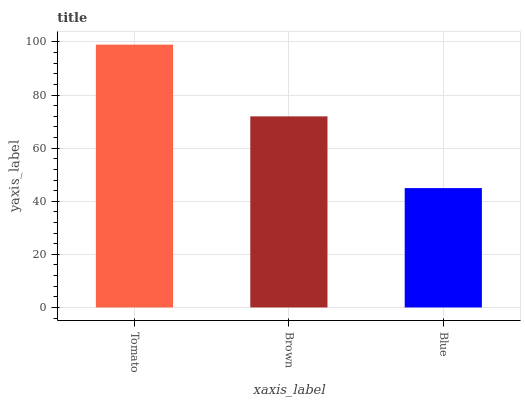Is Blue the minimum?
Answer yes or no. Yes. Is Tomato the maximum?
Answer yes or no. Yes. Is Brown the minimum?
Answer yes or no. No. Is Brown the maximum?
Answer yes or no. No. Is Tomato greater than Brown?
Answer yes or no. Yes. Is Brown less than Tomato?
Answer yes or no. Yes. Is Brown greater than Tomato?
Answer yes or no. No. Is Tomato less than Brown?
Answer yes or no. No. Is Brown the high median?
Answer yes or no. Yes. Is Brown the low median?
Answer yes or no. Yes. Is Tomato the high median?
Answer yes or no. No. Is Tomato the low median?
Answer yes or no. No. 